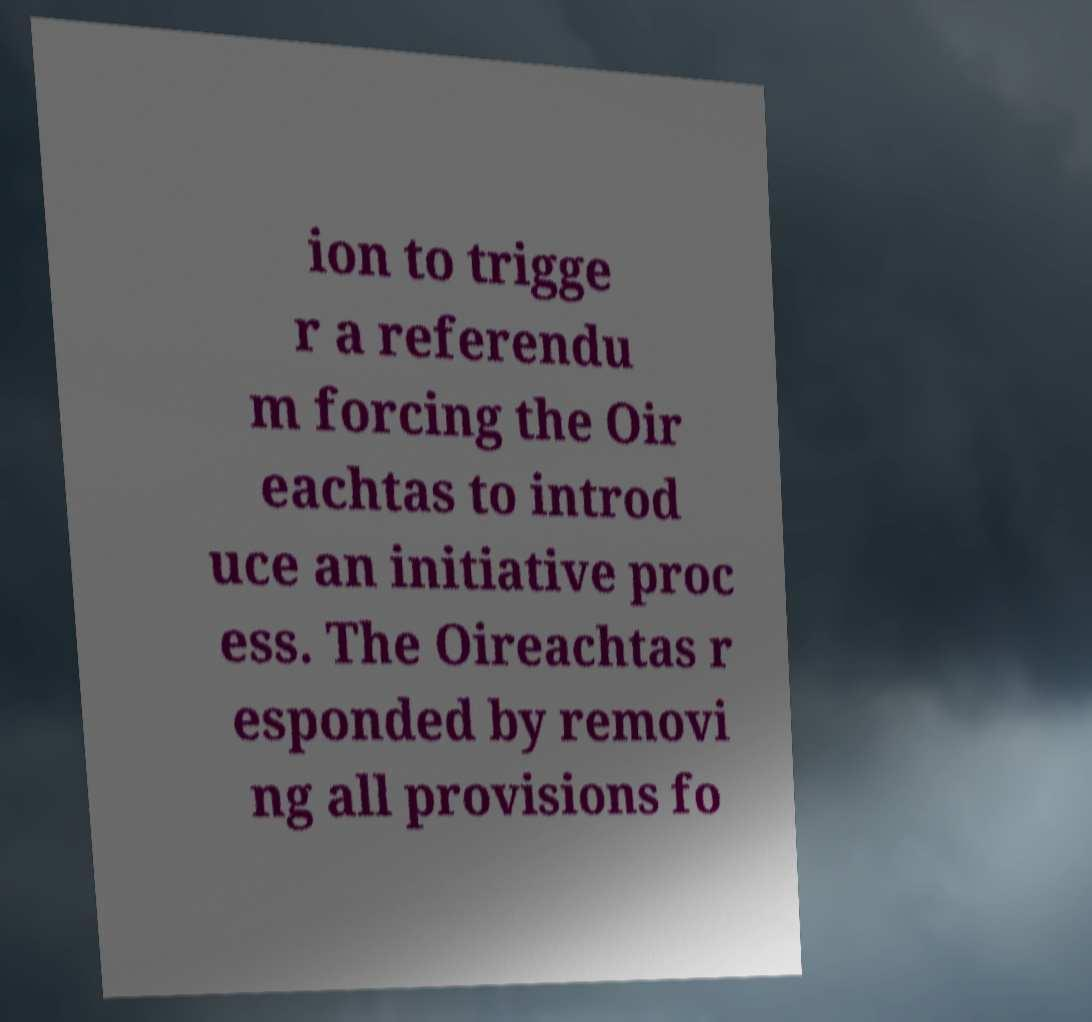Can you read and provide the text displayed in the image?This photo seems to have some interesting text. Can you extract and type it out for me? ion to trigge r a referendu m forcing the Oir eachtas to introd uce an initiative proc ess. The Oireachtas r esponded by removi ng all provisions fo 